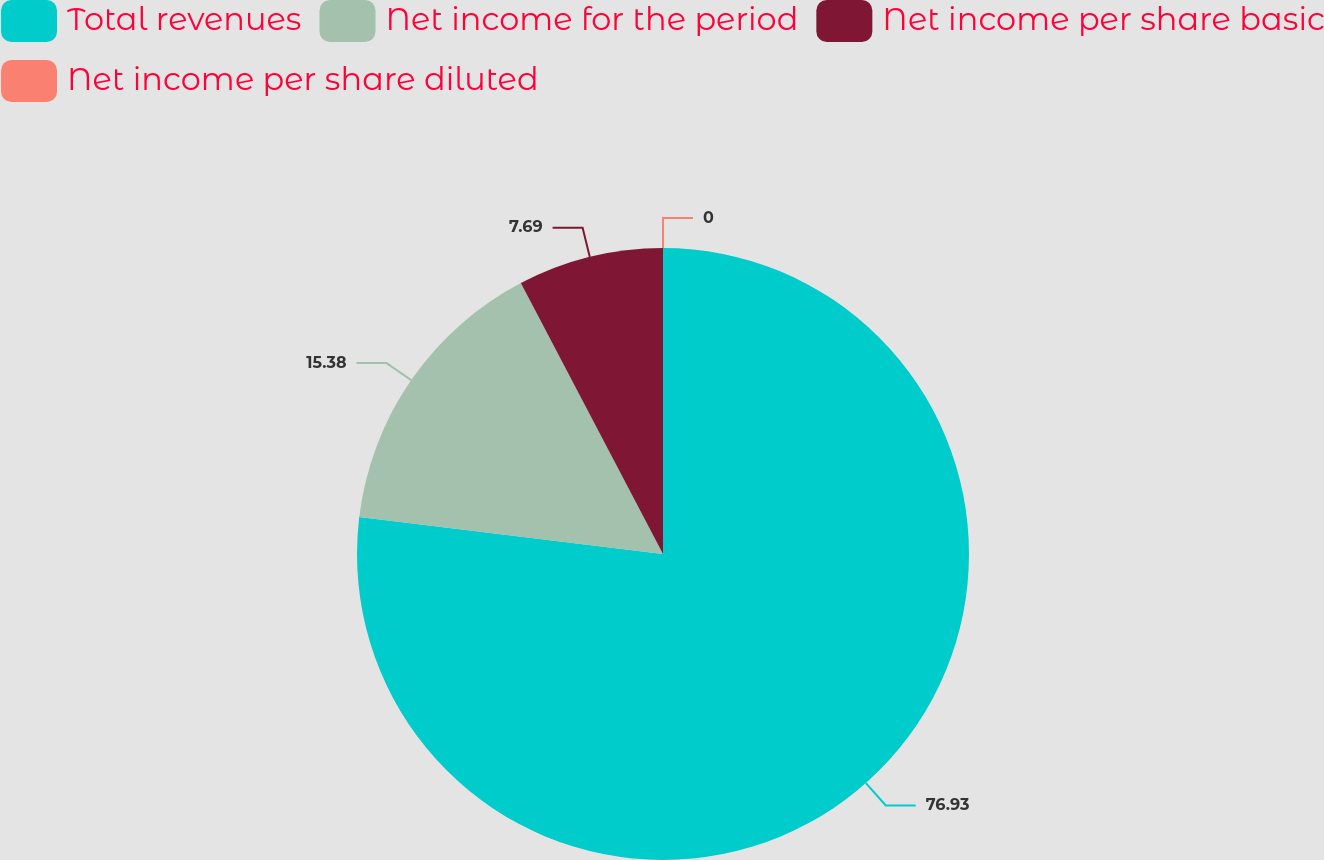Convert chart to OTSL. <chart><loc_0><loc_0><loc_500><loc_500><pie_chart><fcel>Total revenues<fcel>Net income for the period<fcel>Net income per share basic<fcel>Net income per share diluted<nl><fcel>76.92%<fcel>15.38%<fcel>7.69%<fcel>0.0%<nl></chart> 